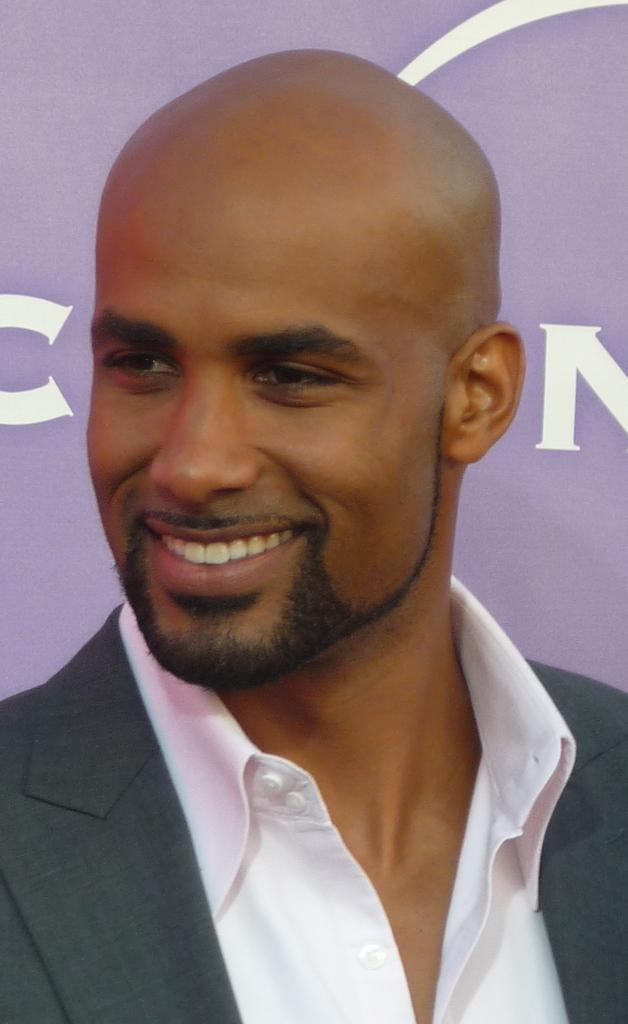Who or what is present in the image? There is a person in the image. What is the person doing or expressing? The person is smiling. What can be seen in the background behind the person? There is a banner behind the person. What type of throat condition does the person in the image have? There is no indication of any throat condition in the image; the person is simply smiling. 